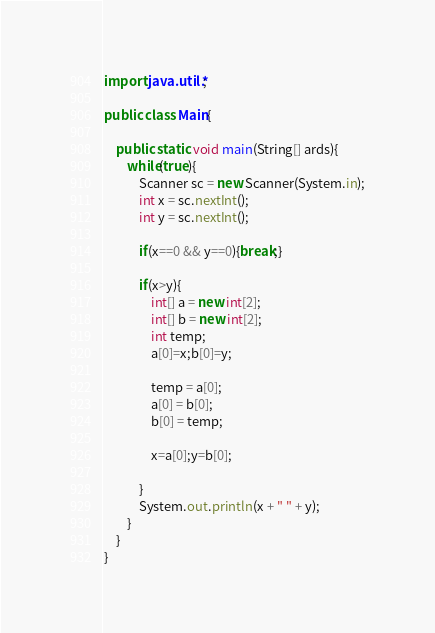Convert code to text. <code><loc_0><loc_0><loc_500><loc_500><_Java_>import java.util.*;

public class Main{

    public static void main(String[] ards){
        while(true){
            Scanner sc = new Scanner(System.in);
            int x = sc.nextInt();
            int y = sc.nextInt();

            if(x==0 && y==0){break;}

            if(x>y){
                int[] a = new int[2];
                int[] b = new int[2];
                int temp;
                a[0]=x;b[0]=y;
        
                temp = a[0];
                a[0] = b[0];
                b[0] = temp;

                x=a[0];y=b[0];

            }
            System.out.println(x + " " + y);
        }
    }
}

</code> 